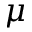<formula> <loc_0><loc_0><loc_500><loc_500>\mu</formula> 